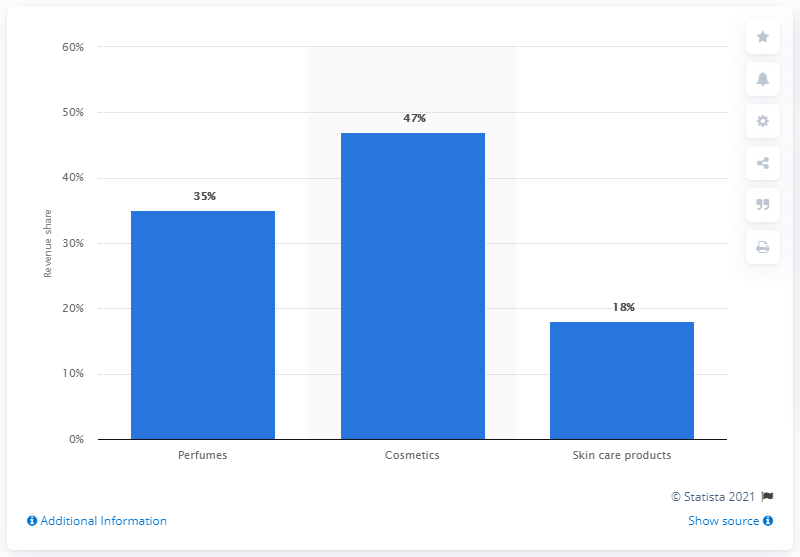Give some essential details in this illustration. LVMH's perfume division accounted for 35% of the company's global revenue in 2018. 